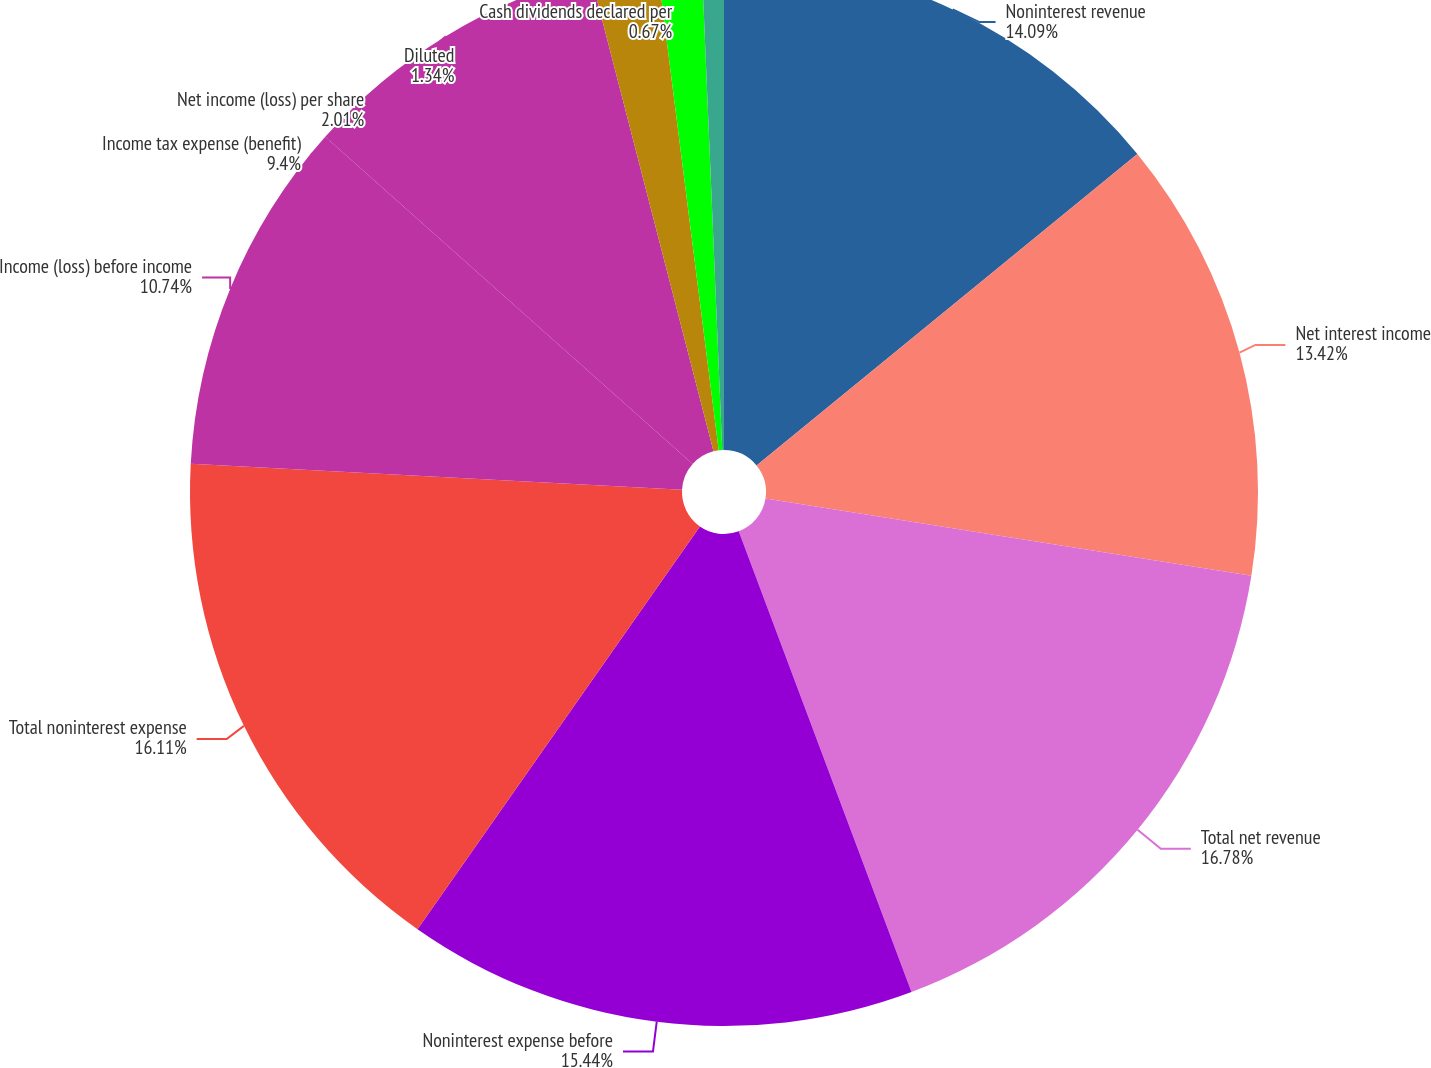<chart> <loc_0><loc_0><loc_500><loc_500><pie_chart><fcel>Noninterest revenue<fcel>Net interest income<fcel>Total net revenue<fcel>Noninterest expense before<fcel>Total noninterest expense<fcel>Income (loss) before income<fcel>Income tax expense (benefit)<fcel>Net income (loss) per share<fcel>Diluted<fcel>Cash dividends declared per<nl><fcel>14.09%<fcel>13.42%<fcel>16.78%<fcel>15.44%<fcel>16.11%<fcel>10.74%<fcel>9.4%<fcel>2.01%<fcel>1.34%<fcel>0.67%<nl></chart> 